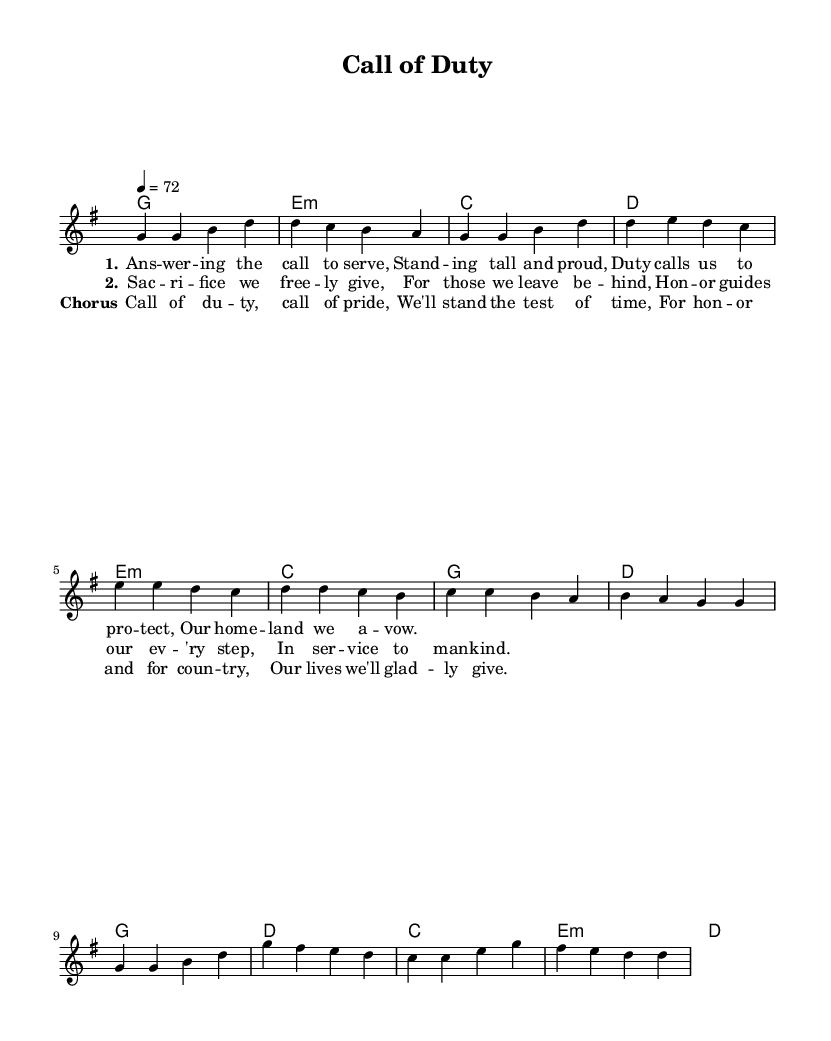What is the key signature of this music? The key signature is G major, which has one sharp (F#). This can be identified at the beginning of the sheet music, where the key signature is notated.
Answer: G major What is the time signature of the piece? The time signature is 4/4, meaning there are four beats in each measure. This is indicated at the beginning of the sheet music next to the key signature.
Answer: 4/4 What is the tempo marking for this piece? The tempo marking indicates a speed of quarter note equals 72 beats per minute. It can be found at the start of the sheet music where the tempo is specified.
Answer: 72 How many verses are present in the lyrics? The lyrics contain two verses, each labeled with a numeral. This can be observed in the lyric sections where "1." and "2." are stated at the beginning of each verse.
Answer: Two What are the main themes explored in the lyrics? The main themes include duty, honor, and sacrifice, which are expressed through phrases in the verses and chorus relating to service and commitment. Analyzing the lyrical content helps identify these recurring themes.
Answer: Duty, honor, sacrifice What is the structure of the song in terms of sections? The structure consists of verses followed by a chorus. This is evident from the arrangement of the lyrics, where two verses precede a chorus section.
Answer: Verse-Chorus Which chord appears in the pre-chorus section? The chords in the pre-chorus include E minor, C, G, and D. By examining the chord changes noted in the harmony section, these can be identified distinctly.
Answer: E minor 